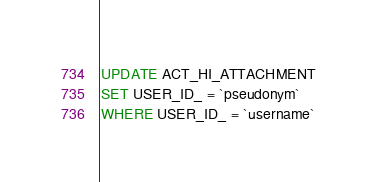Convert code to text. <code><loc_0><loc_0><loc_500><loc_500><_SQL_>UPDATE ACT_HI_ATTACHMENT
SET USER_ID_ = `pseudonym`
WHERE USER_ID_ = `username`
</code> 